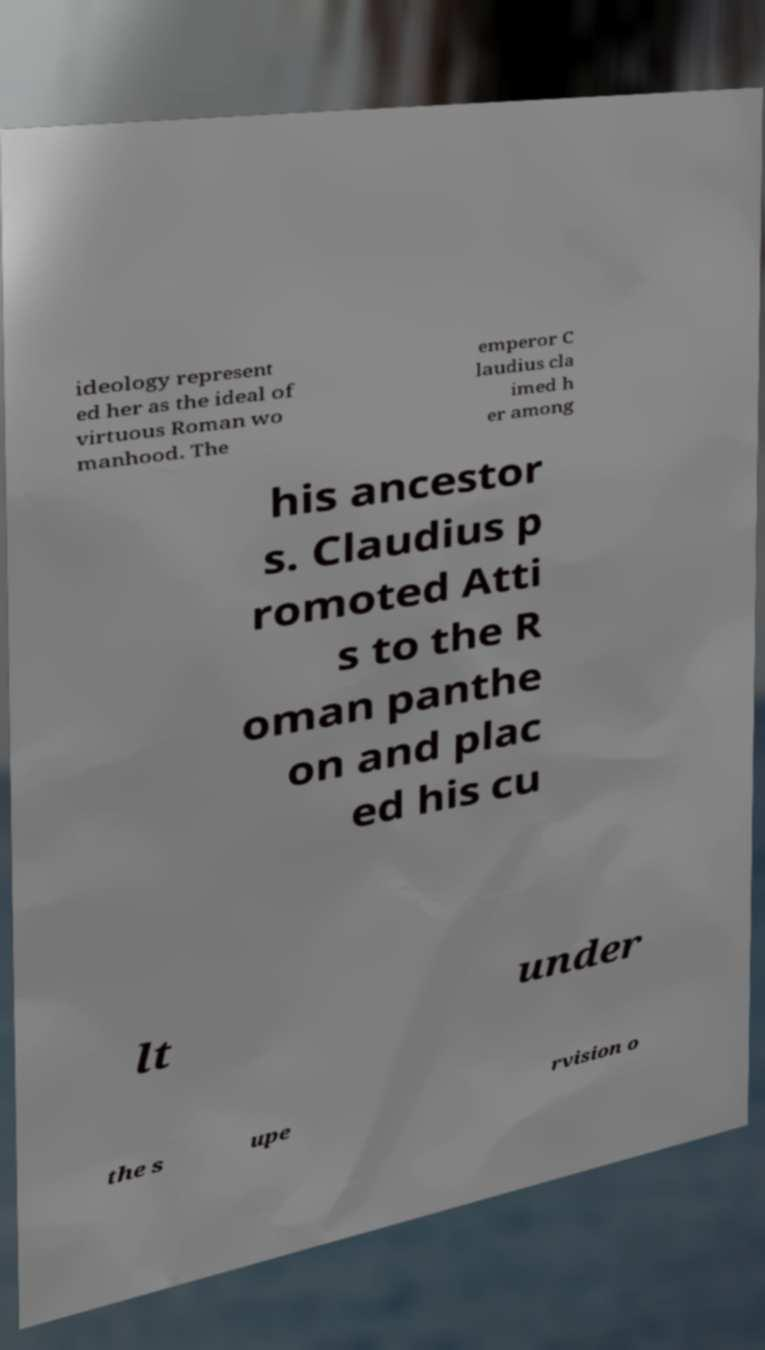I need the written content from this picture converted into text. Can you do that? ideology represent ed her as the ideal of virtuous Roman wo manhood. The emperor C laudius cla imed h er among his ancestor s. Claudius p romoted Atti s to the R oman panthe on and plac ed his cu lt under the s upe rvision o 